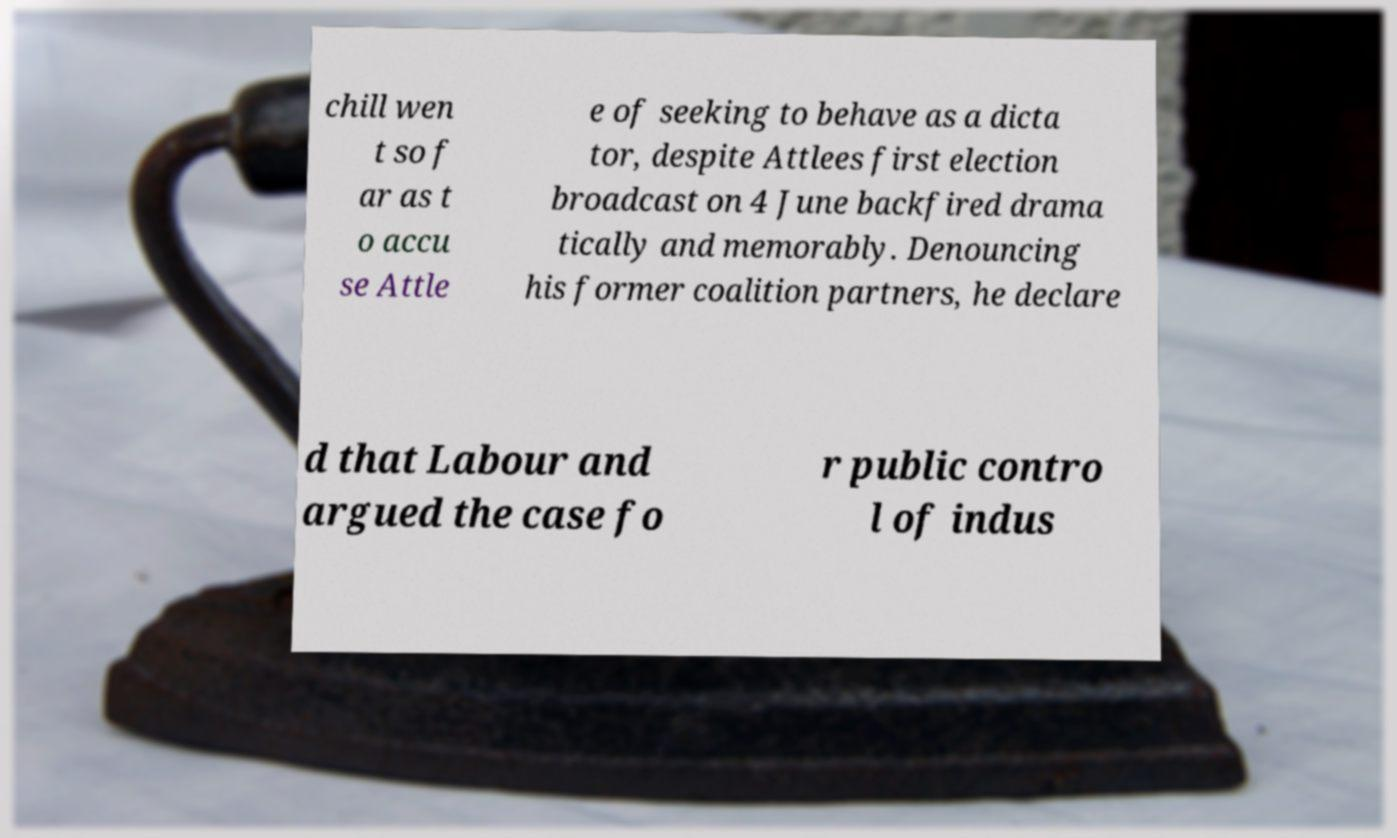Can you read and provide the text displayed in the image?This photo seems to have some interesting text. Can you extract and type it out for me? chill wen t so f ar as t o accu se Attle e of seeking to behave as a dicta tor, despite Attlees first election broadcast on 4 June backfired drama tically and memorably. Denouncing his former coalition partners, he declare d that Labour and argued the case fo r public contro l of indus 